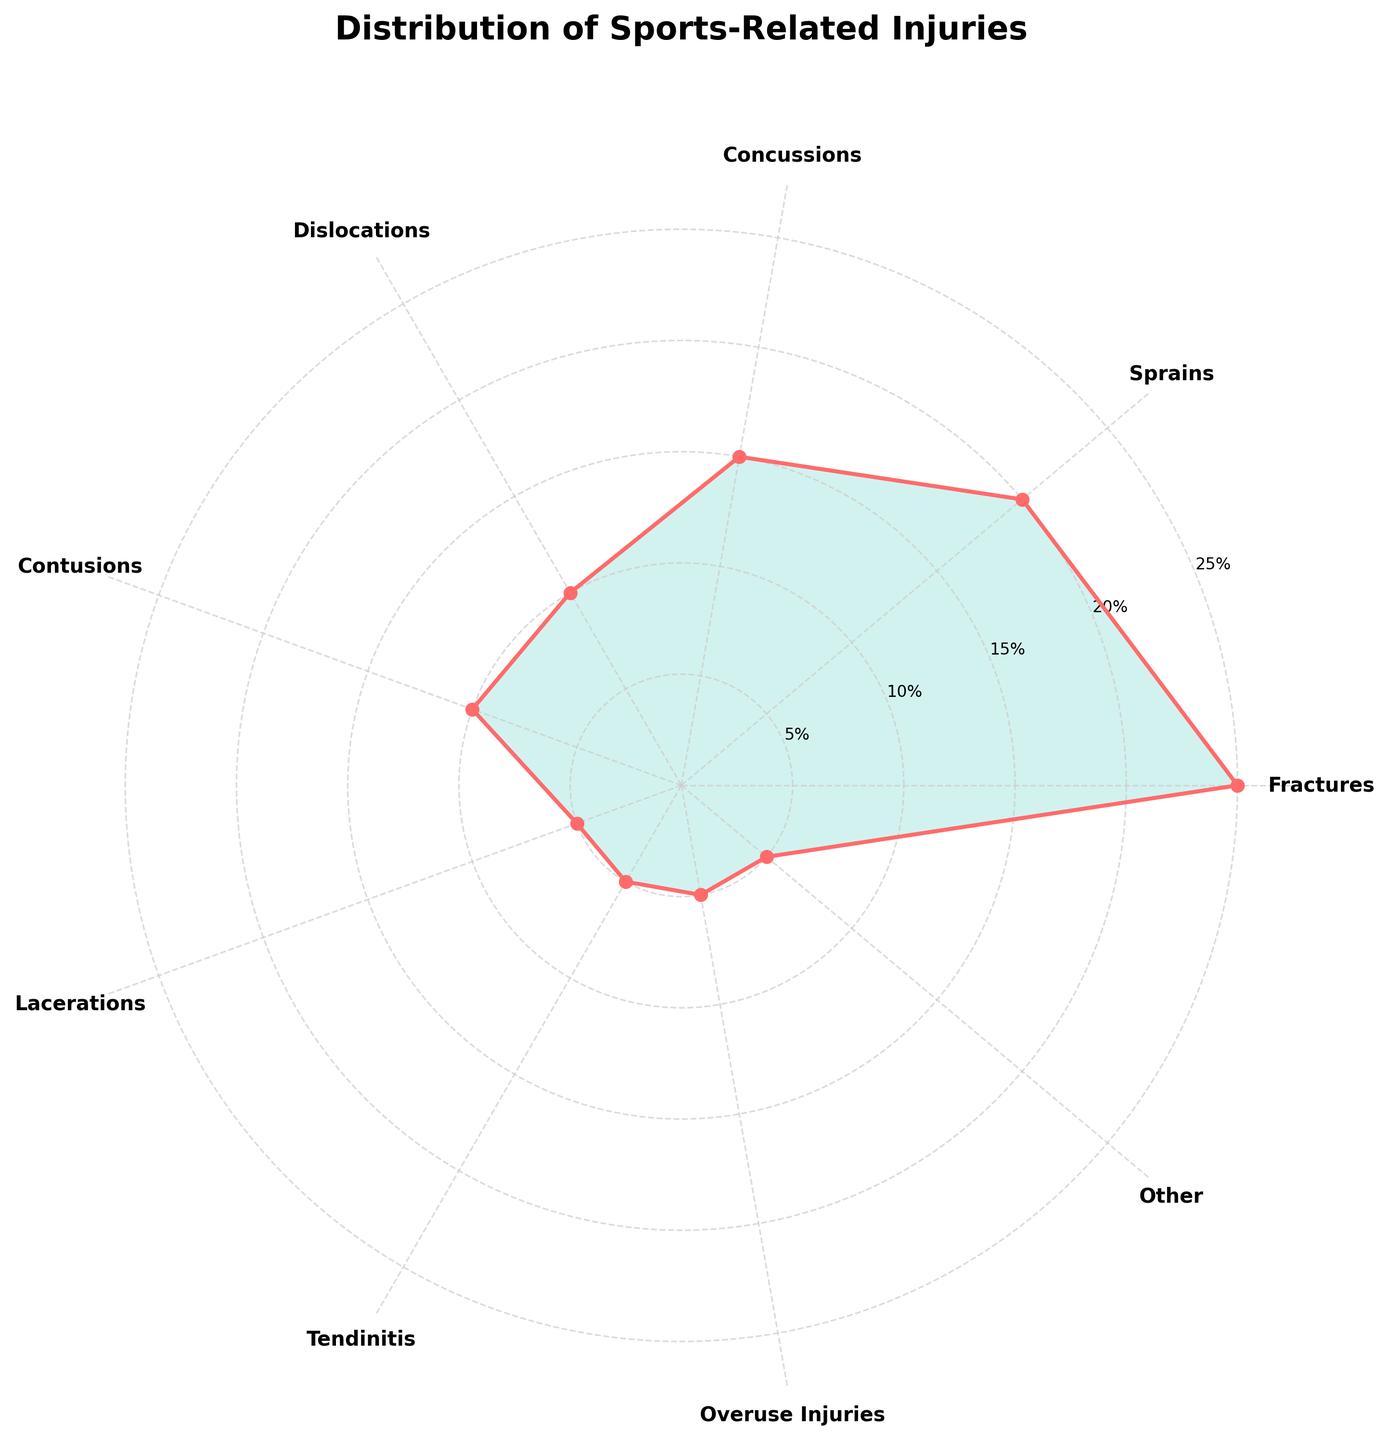What's the most common type of sports-related injury? The figure shows different types of injuries as segments in a polar area chart with corresponding percentages. The largest segment represents Fractures with a percentage of 25%.
Answer: Fractures What's the percentage of sprains relative to the total injuries displayed? From the chart, Sprains are marked with a 20% segment. This represents the percentage of sprains out of the total injuries shown.
Answer: 20% How much greater is the percentage of fractures compared to lacerations? Fractures have a percentage of 25% and Lacerations have a percentage of 5%. The difference is found by subtracting 5% from 25%. Therefore, 25% - 5% = 20%.
Answer: 20% Which injury types share the same percentage and what are they? Observing the polar area chart, Tendinitis, Overuse Injuries, and Other all have the same segment size which is 5%.
Answer: Tendinitis, Overuse Injuries, and Other What's the average percentage of Dislocations and Concussions? Dislocations are 10% and Concussions are 15%. To find the average, sum these two percentages and divide by 2: (10% + 15%) / 2 = 25% / 2 = 12.5%.
Answer: 12.5% Are there more dislocations or contusions? The chart shows that both Dislocations and Contusions have the same percentage of 10% each.
Answer: Equal What is the total percentage of injuries that are categorized as fractures, dislocations, and lacerations? Fractures are 25%, Dislocations are 10%, and Lacerations are 5%. Adding these percentages together yields: 25% + 10% + 5% = 40%.
Answer: 40% What fraction do tendinitis injuries make up relative to sprains? Tendinitis is represented by 5% and Sprains are represented by 20%. The ratio of Tendinitis to Sprains is 5% / 20%. In fraction form, this simplifies to 1/4.
Answer: 1/4 Which injury type is least common, and what is its percentage? The chart shows Tendinitis, Overuse Injuries, and Other all with the lowest percentage of 5%. Therefore, these are the least common injury types.
Answer: Tendinitis, Overuse Injuries, and Other What's the sum of the percentages of 'Contusions' and 'Lacerations'? Contusions have a 10% and Lacerations have 5%. Summing these values gives: 10% + 5% = 15%.
Answer: 15% 